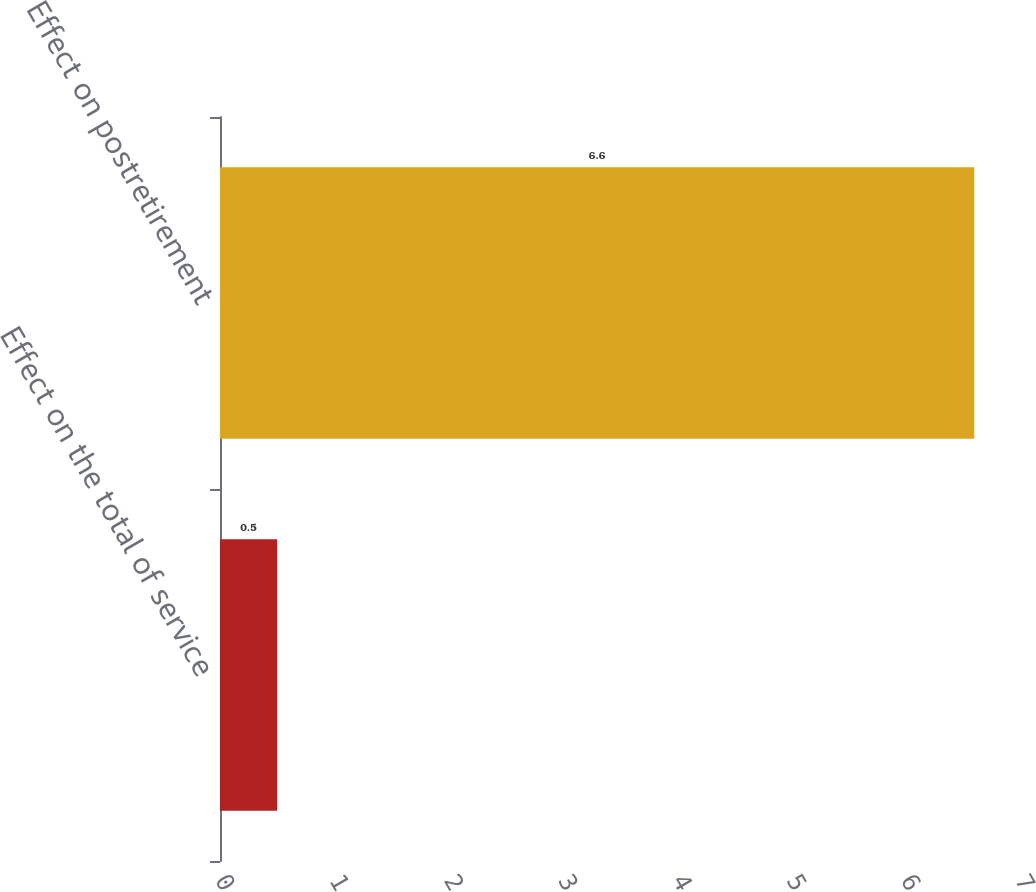Convert chart. <chart><loc_0><loc_0><loc_500><loc_500><bar_chart><fcel>Effect on the total of service<fcel>Effect on postretirement<nl><fcel>0.5<fcel>6.6<nl></chart> 